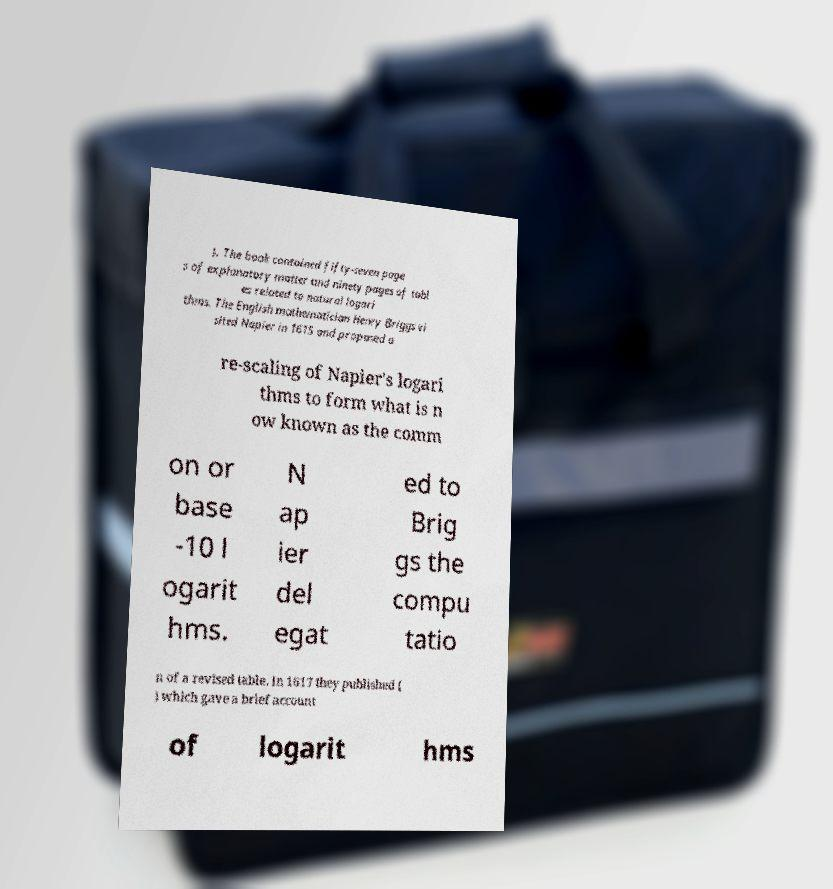For documentation purposes, I need the text within this image transcribed. Could you provide that? ). The book contained fifty-seven page s of explanatory matter and ninety pages of tabl es related to natural logari thms. The English mathematician Henry Briggs vi sited Napier in 1615 and proposed a re-scaling of Napier's logari thms to form what is n ow known as the comm on or base -10 l ogarit hms. N ap ier del egat ed to Brig gs the compu tatio n of a revised table. In 1617 they published ( ) which gave a brief account of logarit hms 